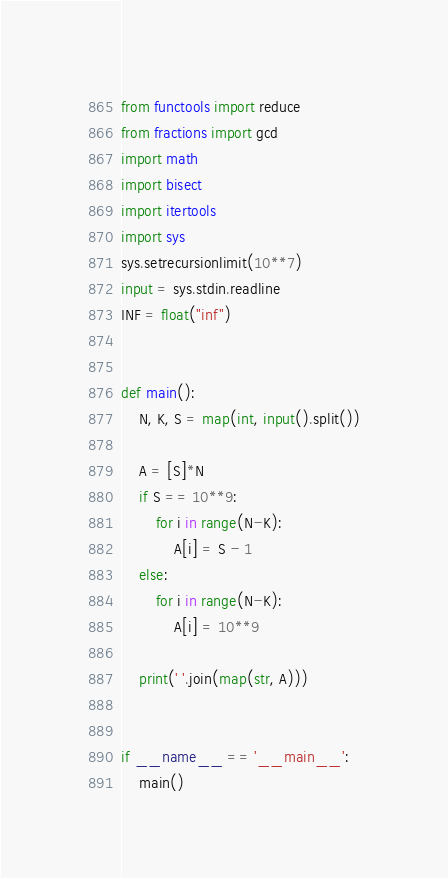<code> <loc_0><loc_0><loc_500><loc_500><_Python_>from functools import reduce
from fractions import gcd
import math
import bisect
import itertools
import sys
sys.setrecursionlimit(10**7)
input = sys.stdin.readline
INF = float("inf")


def main():
    N, K, S = map(int, input().split())
    
    A = [S]*N
    if S == 10**9:
        for i in range(N-K):
            A[i] = S - 1
    else:
        for i in range(N-K):
            A[i] = 10**9

    print(' '.join(map(str, A)))


if __name__ == '__main__':
    main()</code> 